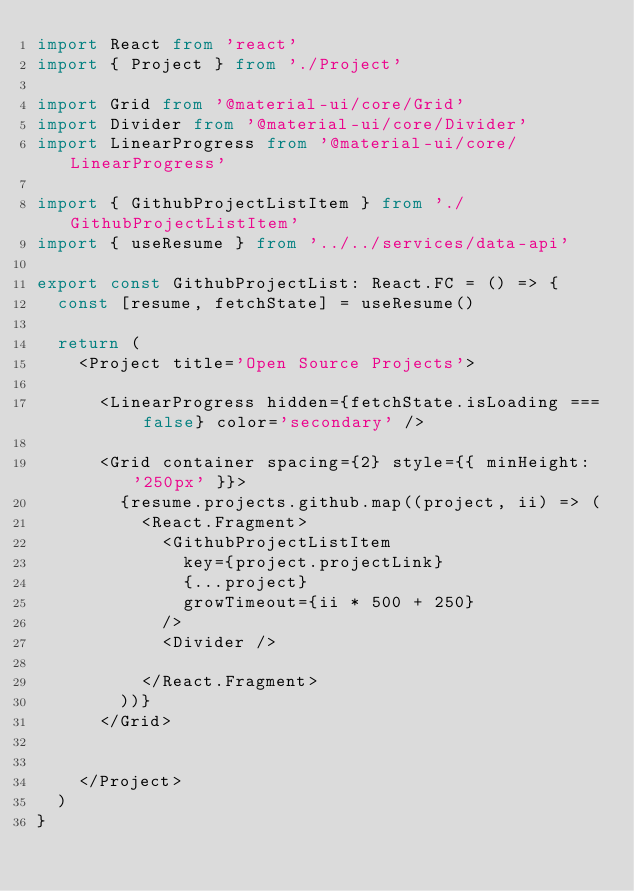<code> <loc_0><loc_0><loc_500><loc_500><_TypeScript_>import React from 'react'
import { Project } from './Project'

import Grid from '@material-ui/core/Grid'
import Divider from '@material-ui/core/Divider'
import LinearProgress from '@material-ui/core/LinearProgress'

import { GithubProjectListItem } from './GithubProjectListItem'
import { useResume } from '../../services/data-api'

export const GithubProjectList: React.FC = () => {
  const [resume, fetchState] = useResume()

  return (
    <Project title='Open Source Projects'>

      <LinearProgress hidden={fetchState.isLoading === false} color='secondary' />

      <Grid container spacing={2} style={{ minHeight: '250px' }}>
        {resume.projects.github.map((project, ii) => (
          <React.Fragment>
            <GithubProjectListItem
              key={project.projectLink}
              {...project}
              growTimeout={ii * 500 + 250}
            />
            <Divider />

          </React.Fragment>
        ))}
      </Grid>


    </Project>
  )
}</code> 